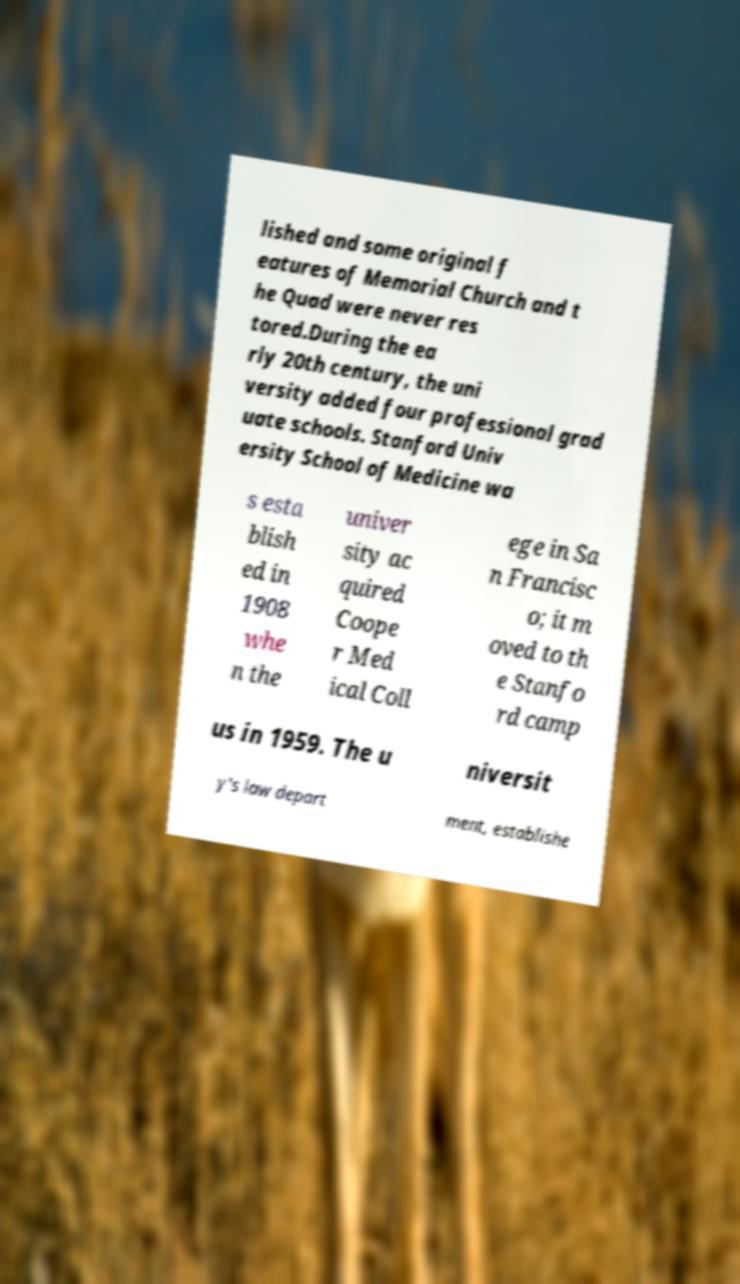Please identify and transcribe the text found in this image. lished and some original f eatures of Memorial Church and t he Quad were never res tored.During the ea rly 20th century, the uni versity added four professional grad uate schools. Stanford Univ ersity School of Medicine wa s esta blish ed in 1908 whe n the univer sity ac quired Coope r Med ical Coll ege in Sa n Francisc o; it m oved to th e Stanfo rd camp us in 1959. The u niversit y's law depart ment, establishe 